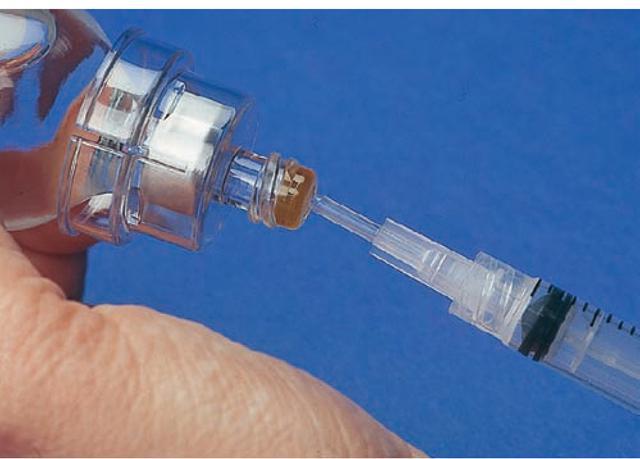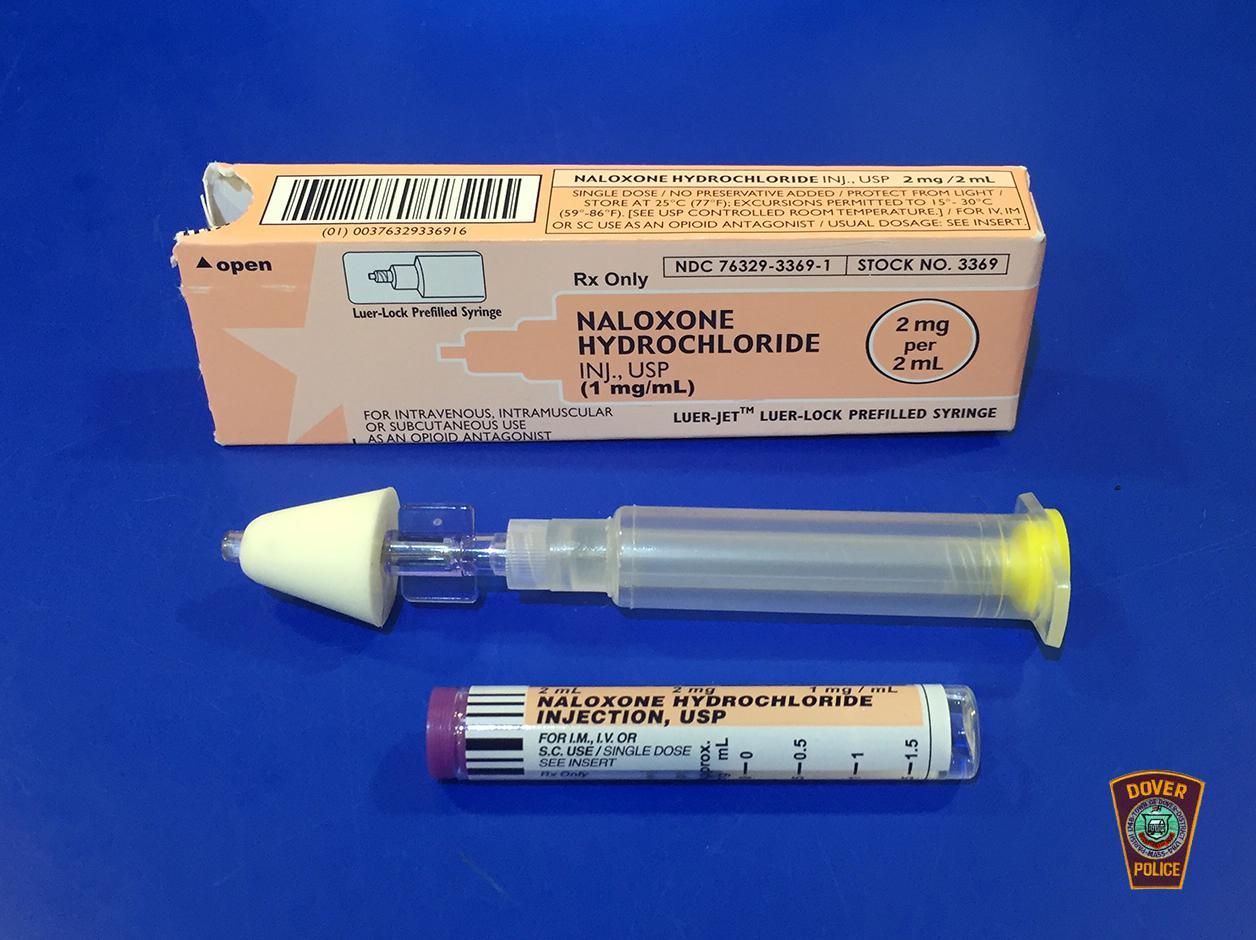The first image is the image on the left, the second image is the image on the right. Evaluate the accuracy of this statement regarding the images: "At least one orange cap is visible in the image on the left.". Is it true? Answer yes or no. No. 